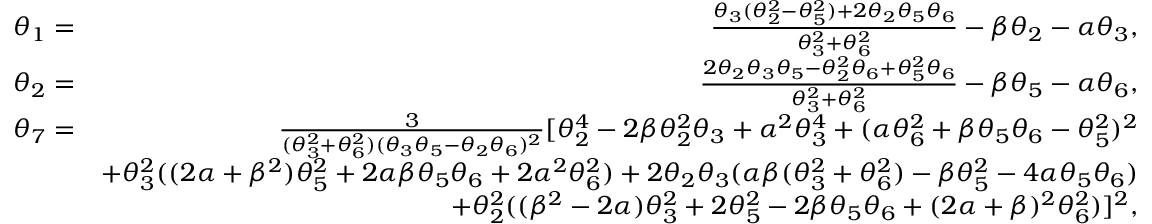Convert formula to latex. <formula><loc_0><loc_0><loc_500><loc_500>\begin{array} { r l r } & { \theta _ { 1 } = } & { \frac { \theta _ { 3 } ( \theta _ { 2 } ^ { 2 } - \theta _ { 5 } ^ { 2 } ) + 2 \theta _ { 2 } \theta _ { 5 } \theta _ { 6 } } { \theta _ { 3 } ^ { 2 } + \theta _ { 6 } ^ { 2 } } - \beta \theta _ { 2 } - \alpha \theta _ { 3 } , } \\ & { \theta _ { 2 } = } & { \frac { 2 \theta _ { 2 } \theta _ { 3 } \theta _ { 5 } - \theta _ { 2 } ^ { 2 } \theta _ { 6 } + \theta _ { 5 } ^ { 2 } \theta _ { 6 } } { \theta _ { 3 } ^ { 2 } + \theta _ { 6 } ^ { 2 } } - \beta \theta _ { 5 } - \alpha \theta _ { 6 } , } \\ & { \theta _ { 7 } = } & { \frac { 3 } { ( \theta _ { 3 } ^ { 2 } + \theta _ { 6 } ^ { 2 } ) ( \theta _ { 3 } \theta _ { 5 } - \theta _ { 2 } \theta _ { 6 } ) ^ { 2 } } [ \theta _ { 2 } ^ { 4 } - 2 \beta \theta _ { 2 } ^ { 2 } \theta _ { 3 } + \alpha ^ { 2 } \theta _ { 3 } ^ { 4 } + ( \alpha \theta _ { 6 } ^ { 2 } + \beta \theta _ { 5 } \theta _ { 6 } - \theta _ { 5 } ^ { 2 } ) ^ { 2 } } \\ & { + \theta _ { 3 } ^ { 2 } ( ( 2 \alpha + \beta ^ { 2 } ) \theta _ { 5 } ^ { 2 } + 2 \alpha \beta \theta _ { 5 } \theta _ { 6 } + 2 \alpha ^ { 2 } \theta _ { 6 } ^ { 2 } ) + 2 \theta _ { 2 } \theta _ { 3 } ( \alpha \beta ( \theta _ { 3 } ^ { 2 } + \theta _ { 6 } ^ { 2 } ) - \beta \theta _ { 5 } ^ { 2 } - 4 \alpha \theta _ { 5 } \theta _ { 6 } ) } \\ & { + \theta _ { 2 } ^ { 2 } ( ( \beta ^ { 2 } - 2 \alpha ) \theta _ { 3 } ^ { 2 } + 2 \theta _ { 5 } ^ { 2 } - 2 \beta \theta _ { 5 } \theta _ { 6 } + ( 2 \alpha + \beta ) ^ { 2 } \theta _ { 6 } ^ { 2 } ) ] ^ { 2 } , } \end{array}</formula> 